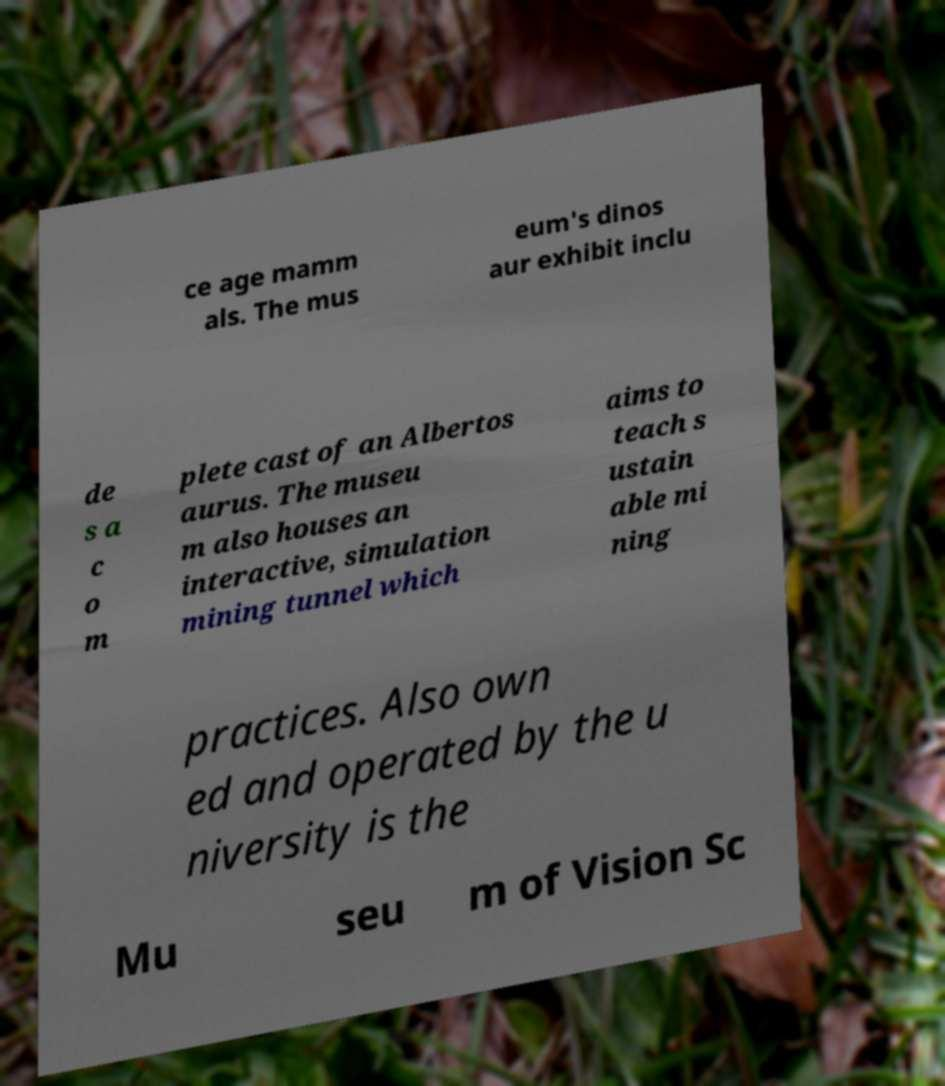There's text embedded in this image that I need extracted. Can you transcribe it verbatim? ce age mamm als. The mus eum's dinos aur exhibit inclu de s a c o m plete cast of an Albertos aurus. The museu m also houses an interactive, simulation mining tunnel which aims to teach s ustain able mi ning practices. Also own ed and operated by the u niversity is the Mu seu m of Vision Sc 